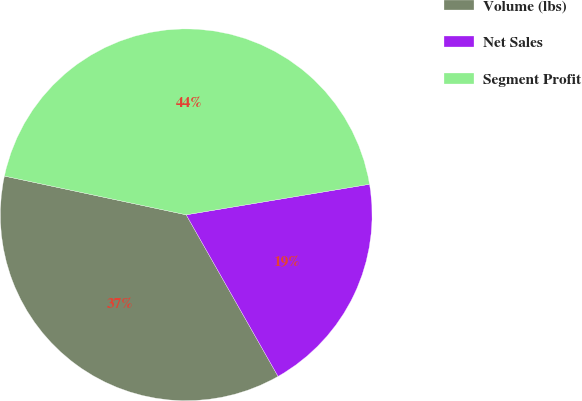Convert chart to OTSL. <chart><loc_0><loc_0><loc_500><loc_500><pie_chart><fcel>Volume (lbs)<fcel>Net Sales<fcel>Segment Profit<nl><fcel>36.57%<fcel>19.4%<fcel>44.03%<nl></chart> 